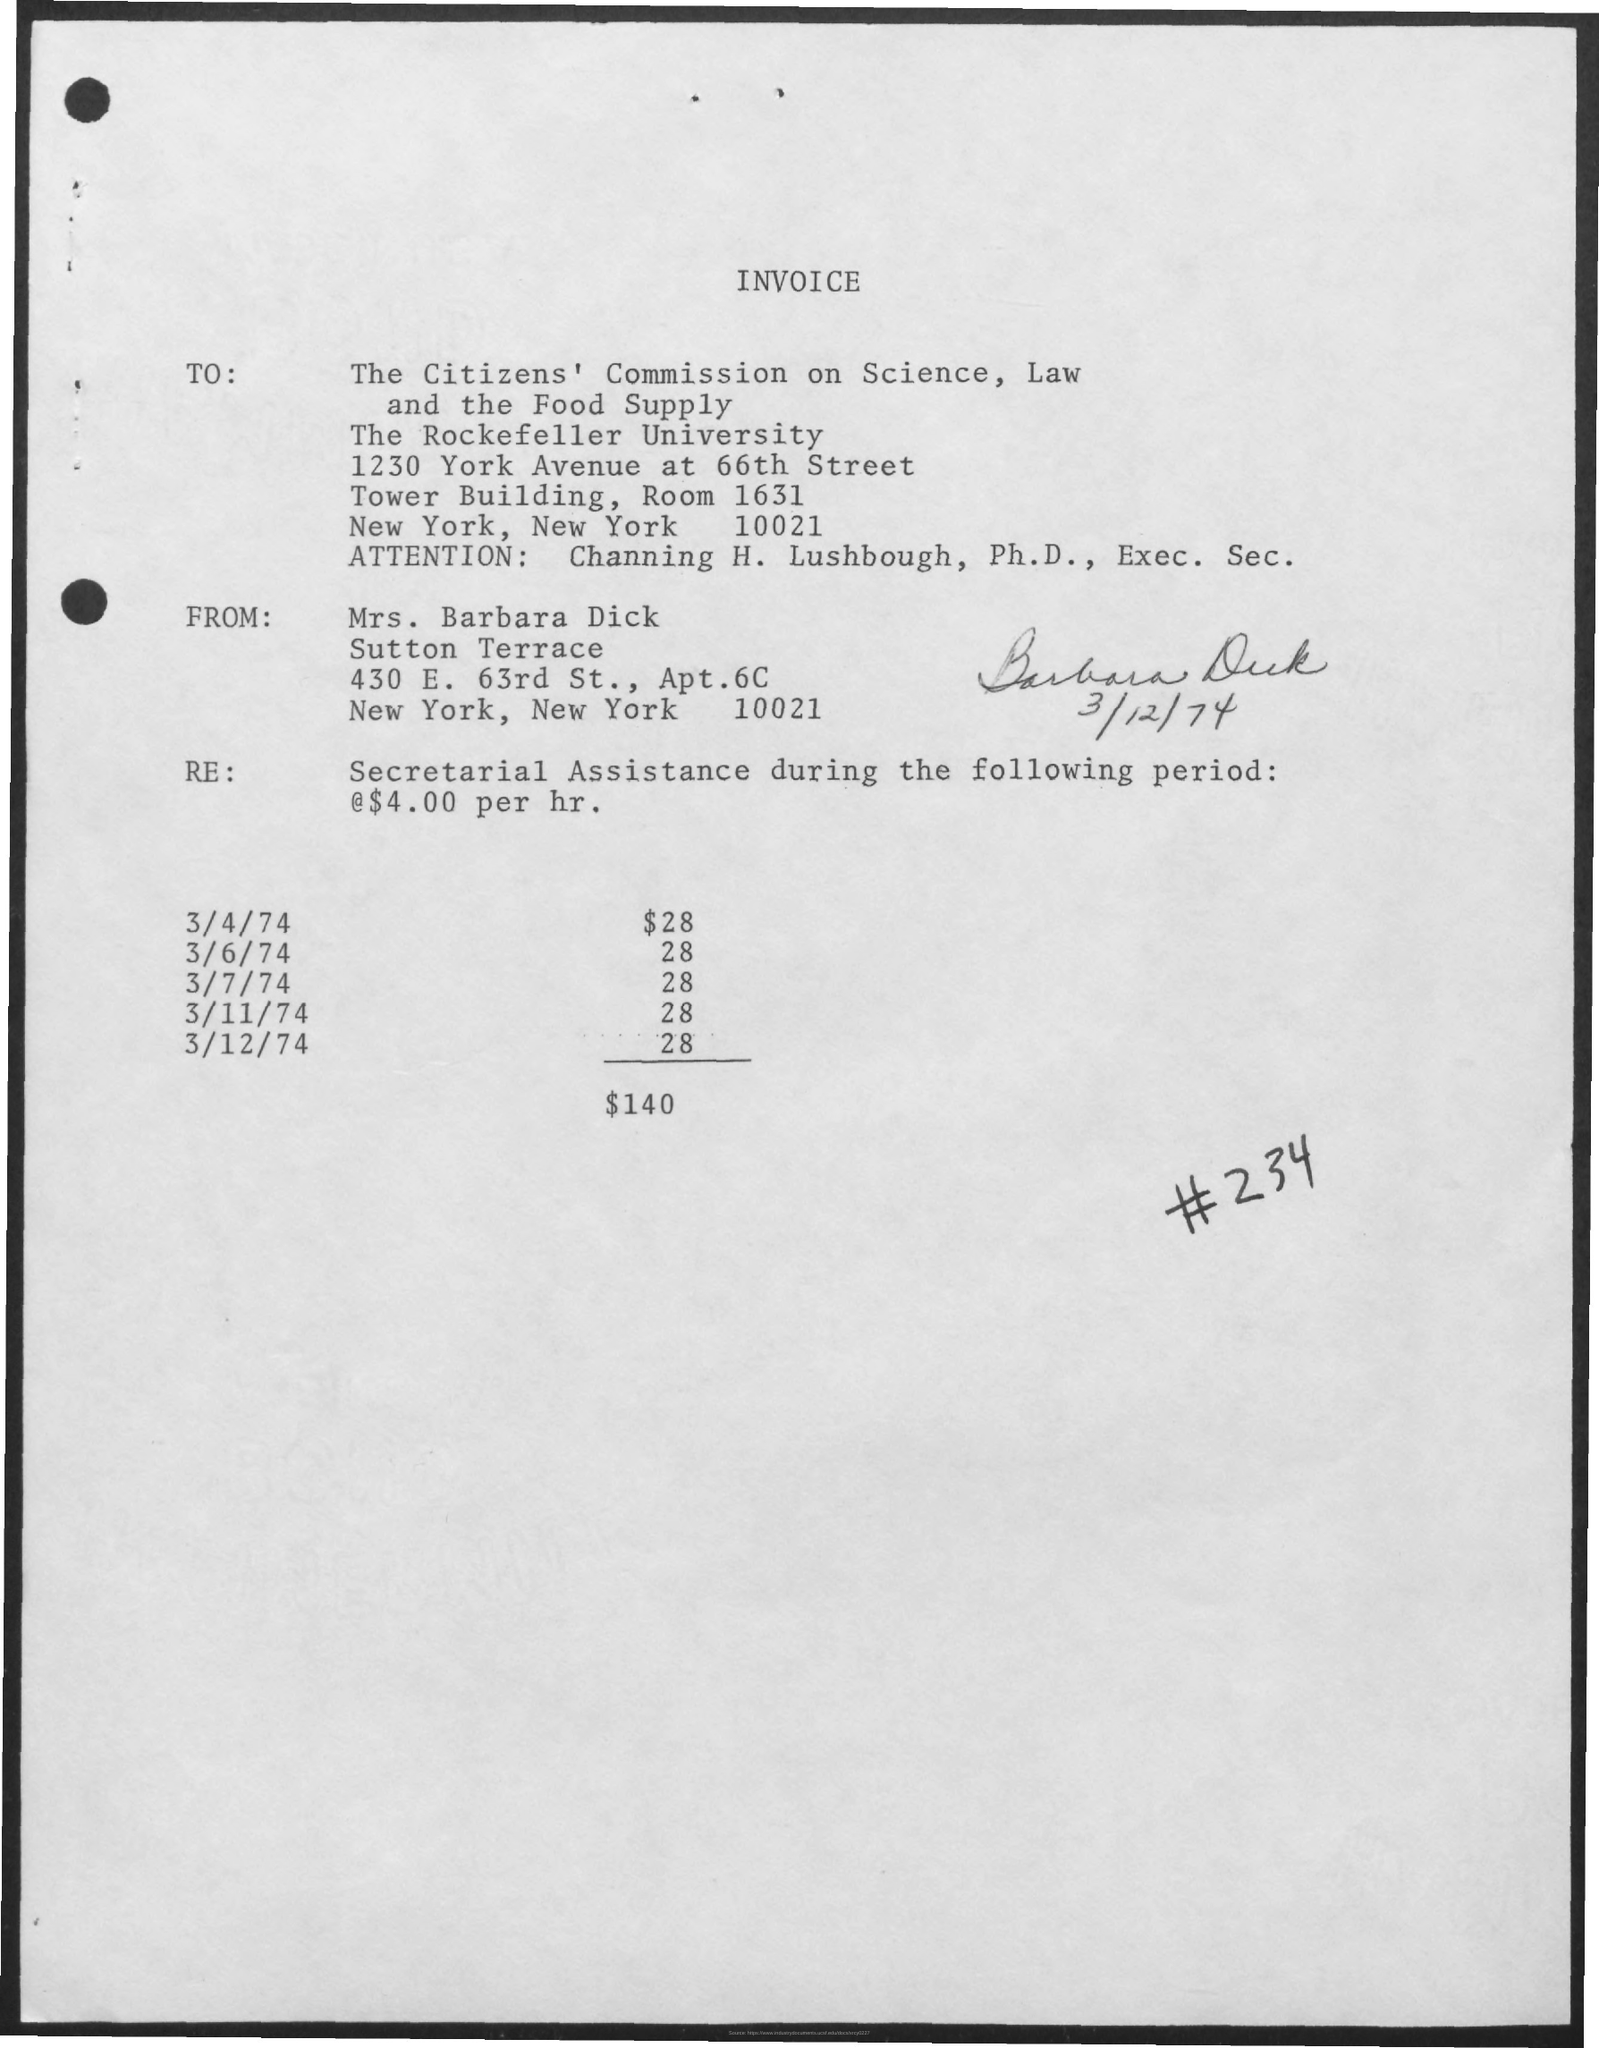Outline some significant characteristics in this image. The total amount of the invoice is $140. To whom is the invoice addressed? The invoice is addressed to the Citizens' Commission on Science, Law and the Food Supply. The invoice is sent by Mrs. Barbara Dick. 